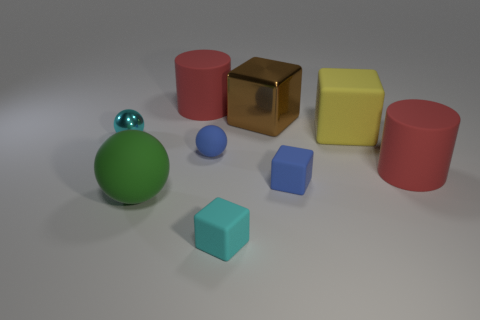Subtract all rubber balls. How many balls are left? 1 Subtract all brown blocks. How many blocks are left? 3 Add 1 red rubber cylinders. How many objects exist? 10 Subtract all gray balls. Subtract all red cubes. How many balls are left? 3 Subtract all cylinders. How many objects are left? 7 Add 4 tiny blue rubber things. How many tiny blue rubber things exist? 6 Subtract 0 blue cylinders. How many objects are left? 9 Subtract all tiny green spheres. Subtract all tiny objects. How many objects are left? 5 Add 4 small spheres. How many small spheres are left? 6 